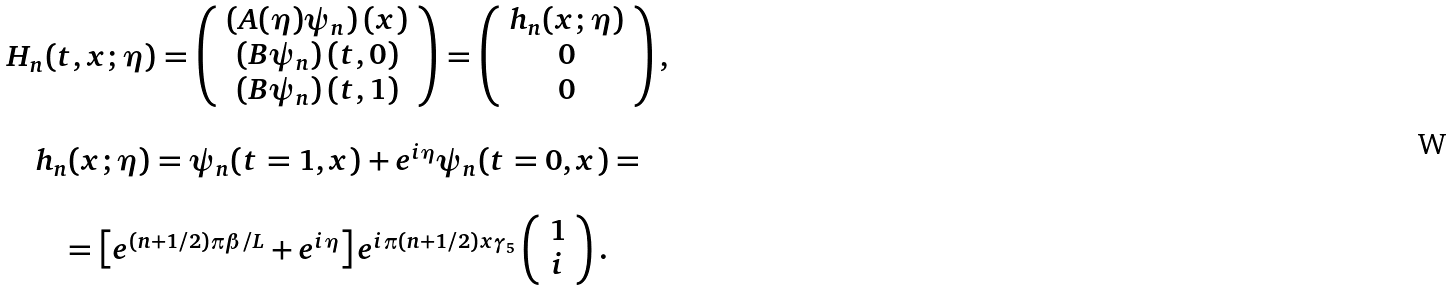Convert formula to latex. <formula><loc_0><loc_0><loc_500><loc_500>\begin{array} { c } H _ { n } ( t , x ; \eta ) = \left ( \begin{array} { c } \left ( A ( \eta ) \psi _ { n } \right ) ( x ) \\ \left ( B \psi _ { n } \right ) ( t , 0 ) \\ \left ( B \psi _ { n } \right ) ( t , 1 ) \end{array} \right ) = \left ( \begin{array} { c } h _ { n } ( x ; \eta ) \\ 0 \\ 0 \end{array} \right ) , \\ \\ h _ { n } ( x ; \eta ) = \psi _ { n } ( t = 1 , x ) + e ^ { i \eta } \psi _ { n } ( t = 0 , x ) = \\ \\ = \left [ e ^ { ( n + 1 / 2 ) \pi \beta / L } + e ^ { i \eta } \right ] e ^ { i \pi ( n + 1 / 2 ) x \gamma _ { 5 } } \left ( \begin{array} { c } 1 \\ i \end{array} \right ) . \end{array}</formula> 